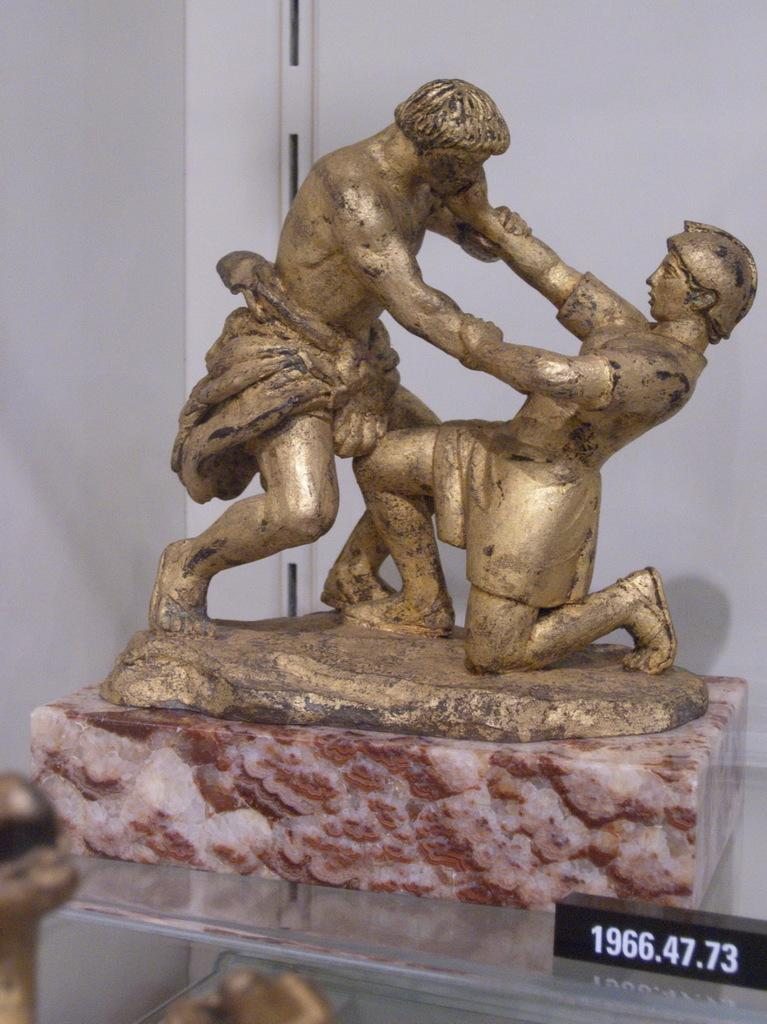What is the main subject of the image? There is a statue in the image. Where is the statue located? The statue is placed on a table. What can be seen in the background of the image? There is a name label and walls visible in the background of the image. What flavor of ice cream is being served on the statue's knee in the image? There is no ice cream or knee present on the statue in the image. 